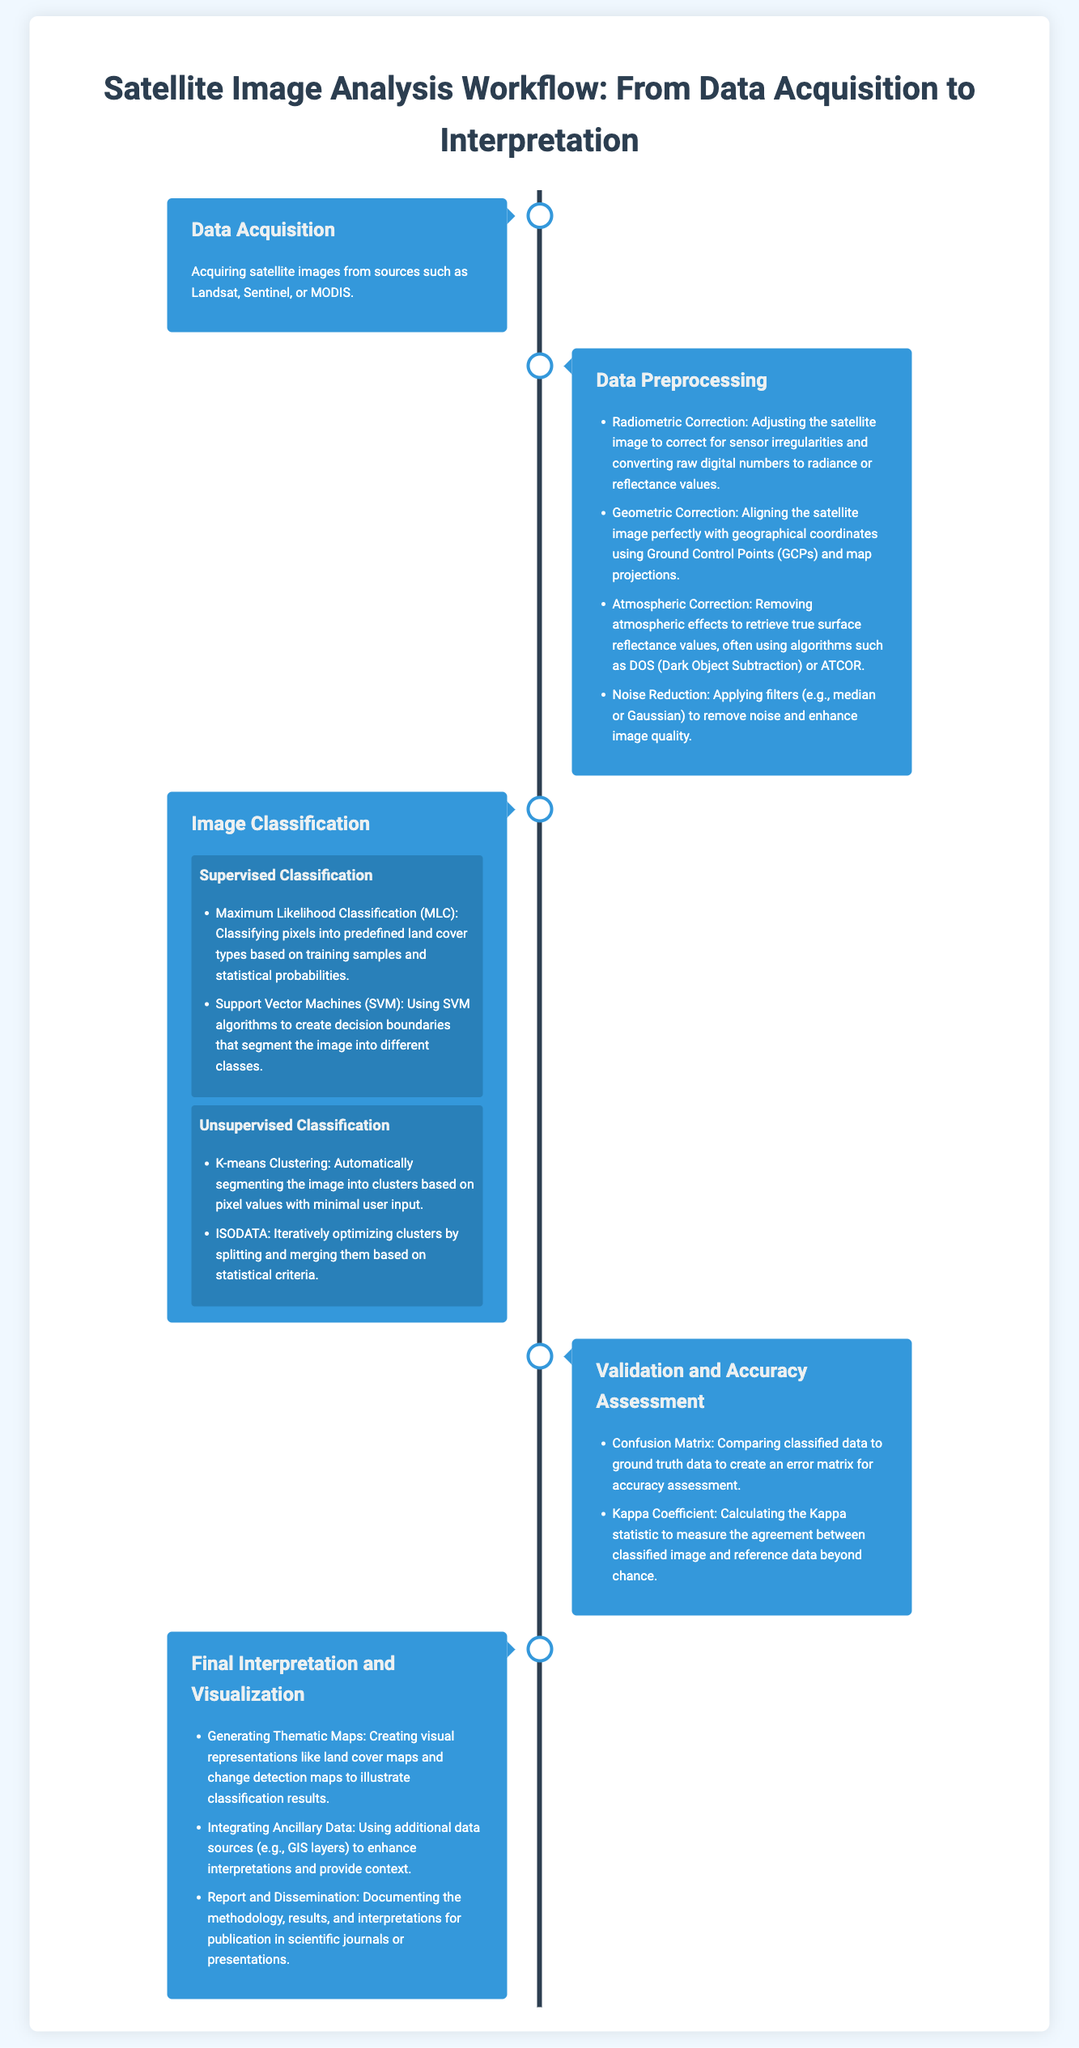What is the first step in the satellite image analysis workflow? The first step in the workflow is specified as Data Acquisition, which involves acquiring satellite images.
Answer: Data Acquisition What types of classification methods are mentioned? The document lists Supervised Classification and Unsupervised Classification as the main types of classification methods used.
Answer: Supervised Classification and Unsupervised Classification Which algorithm is listed for Radiometric Correction? The document does not specify an algorithm for Radiometric Correction but mentions the need for adjusting satellite images for sensor irregularities.
Answer: None What technique is used for atmospheric correction? The document mentions using algorithms such as DOS (Dark Object Subtraction) or ATCOR for atmospheric correction.
Answer: DOS and ATCOR What visual representation is created in the final interpretation step? The final interpretation step involves generating thematic maps, which are visual representations of the classification results.
Answer: Thematic Maps What matrix is used for accuracy assessment? The Confusion Matrix is used for comparing classified data to ground truth data for accuracy assessment.
Answer: Confusion Matrix How many sub-methods are listed under Unsupervised Classification? There are two sub-methods listed under Unsupervised Classification: K-means Clustering and ISODATA.
Answer: Two What is the purpose of the Kappa Coefficient in the process? The Kappa Coefficient is used to measure the agreement between classified image and reference data beyond chance during validation.
Answer: Measure agreement What is included in the report and dissemination step? The report and dissemination step includes documenting the methodology, results, and interpretations for publication.
Answer: Documenting methodology and results 